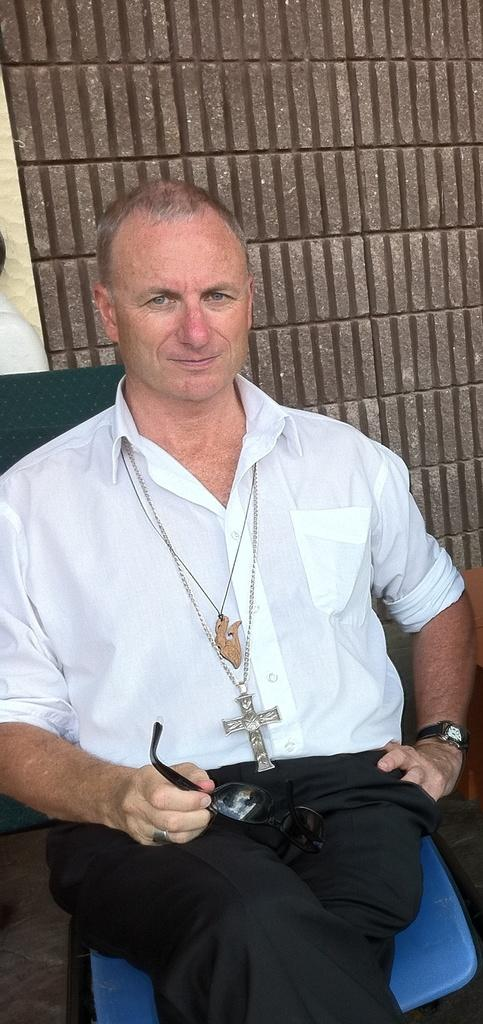What is the main subject of the image? There is a person sitting on a chair in the image. What is the person holding in the image? The person is holding spectacles. Can you describe the background of the image? There is a wall in the background of the image, and there is another person visible, but they appear to be partially obscured or truncated. How many cakes are on the table in the image? There is no table or cakes present in the image. What type of coach is visible in the image? There is no coach present in the image. 